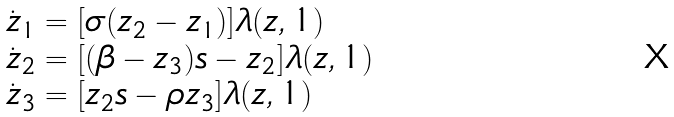<formula> <loc_0><loc_0><loc_500><loc_500>\begin{array} { l } \dot { z } _ { 1 } = [ \sigma ( z _ { 2 } - z _ { 1 } ) ] \lambda ( z , 1 ) \\ \dot { z } _ { 2 } = [ ( \beta - z _ { 3 } ) s - z _ { 2 } ] \lambda ( z , 1 ) \\ \dot { z } _ { 3 } = [ z _ { 2 } s - \rho z _ { 3 } ] \lambda ( z , 1 ) \end{array}</formula> 